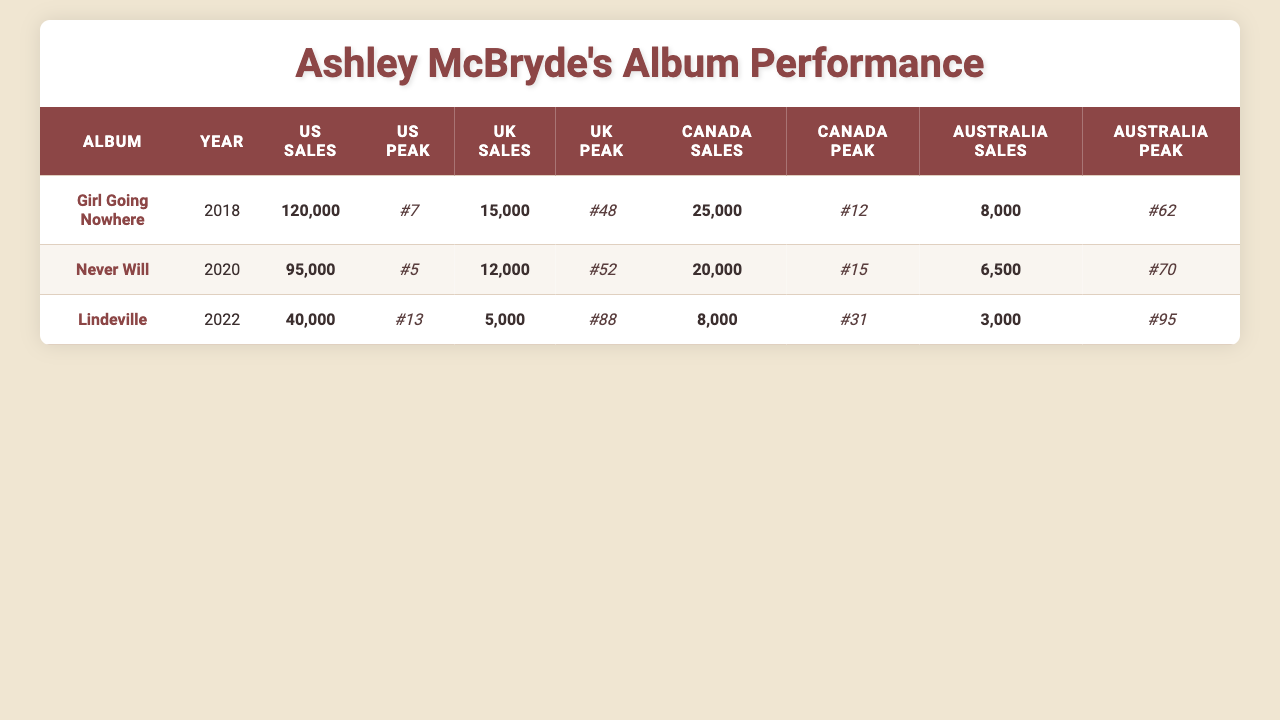What is the peak chart position of "Girl Going Nowhere" in the US? The peak chart position of "Girl Going Nowhere" in the US is directly listed in the table as 7.
Answer: 7 How many units did "Never Will" sell in Canada? The units sold for "Never Will" in Canada are specified in the table as 20,000.
Answer: 20,000 Which album has the highest sales in the US? By comparing the US sales figures in the table, "Girl Going Nowhere" has the highest sales at 120,000 units.
Answer: Girl Going Nowhere What is the total sales for all albums in the UK? To find the total sales in the UK, add up the sales from each album: 15,000 (Girl Going Nowhere) + 12,000 (Never Will) + 5,000 (Lindeville) = 32,000.
Answer: 32,000 What is the average peak position of Ashley McBryde's albums in Australia? The peak positions in Australia are 62 (Girl Going Nowhere), 70 (Never Will), and 95 (Lindeville). Calculate the average: (62 + 70 + 95) / 3 = 75.67, which can be rounded to 76.
Answer: 76 Is the sales figure of "Lindeville" higher than that of "Never Will" in any country? Checking the table, "Lindeville" sold 40,000 in the US, which is higher than "Never Will" at 95,000. In all other countries, its sales figures are lower than "Never Will".
Answer: No What percentage of "Girl Going Nowhere" sales does its UK sales represent? First, find the total sales for "Girl Going Nowhere": 120,000 (US sales). UK sales are 15,000. To get the percentage: (15,000 / 120,000) * 100 = 12.5%.
Answer: 12.5% How does "Australia Sales" of each album compare to their US Sales? For comparison: "Girl Going Nowhere" (8,000 in Australia vs 120,000 in US), "Never Will" (6,500 in Australia vs 95,000 in US), "Lindeville" (3,000 in Australia vs 40,000 in US). All Australian sales are significantly less than their US sales.
Answer: All albums sold significantly less in Australia than in the US Which album had the largest gap between its US peak position and its UK peak position? The gaps are 7 - 48 = -41 (Girl Going Nowhere), 5 - 52 = -47 (Never Will), and 13 - 88 = -75 (Lindeville). The largest negative gap is for "Lindeville" with -75.
Answer: Lindeville 